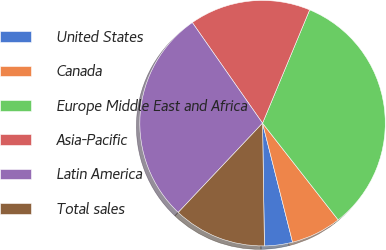Convert chart. <chart><loc_0><loc_0><loc_500><loc_500><pie_chart><fcel>United States<fcel>Canada<fcel>Europe Middle East and Africa<fcel>Asia-Pacific<fcel>Latin America<fcel>Total sales<nl><fcel>3.69%<fcel>6.63%<fcel>33.17%<fcel>15.97%<fcel>28.26%<fcel>12.29%<nl></chart> 